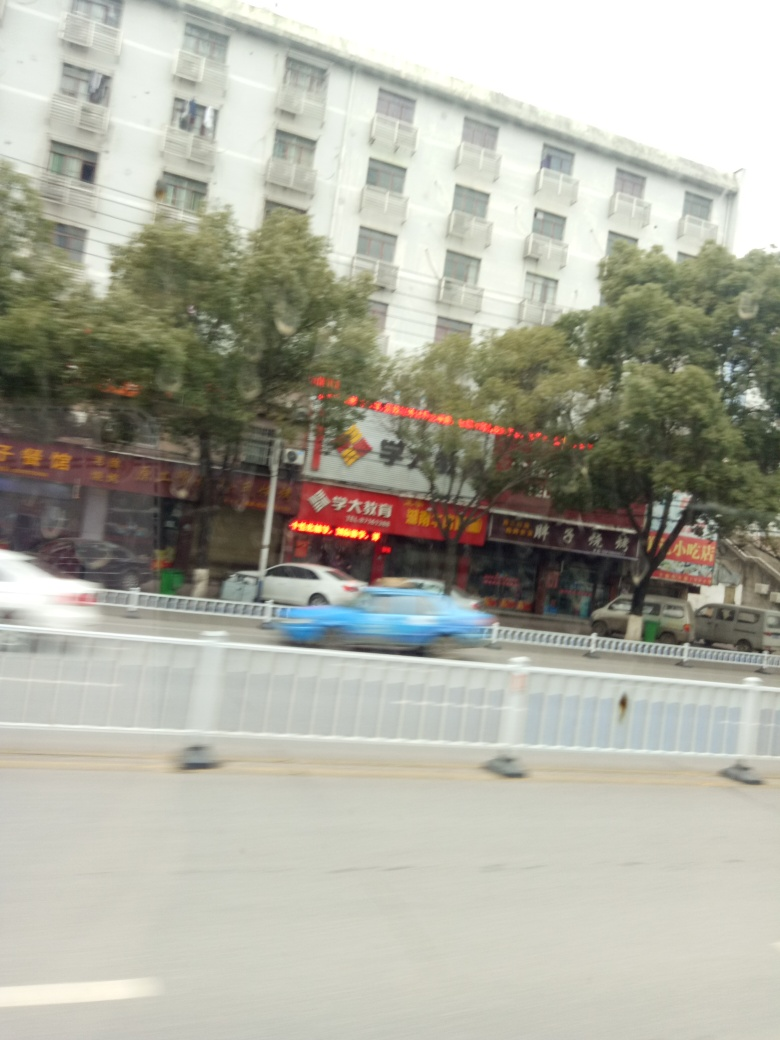Describe the weather or time of day conveyed in this image. The image appears to have been taken during the day under overcast sky conditions, which are indicative of either early morning or late afternoon, given the diffused nature of the natural light and the absence of strong shadows. 